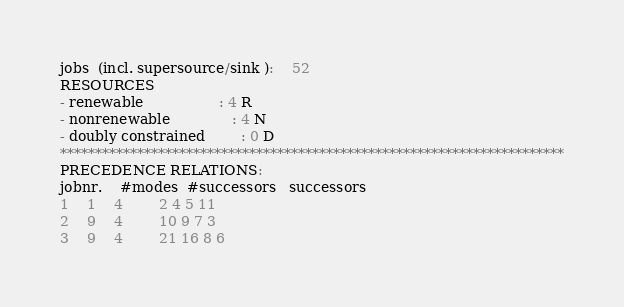Convert code to text. <code><loc_0><loc_0><loc_500><loc_500><_ObjectiveC_>jobs  (incl. supersource/sink ):	52
RESOURCES
- renewable                 : 4 R
- nonrenewable              : 4 N
- doubly constrained        : 0 D
************************************************************************
PRECEDENCE RELATIONS:
jobnr.    #modes  #successors   successors
1	1	4		2 4 5 11 
2	9	4		10 9 7 3 
3	9	4		21 16 8 6 </code> 